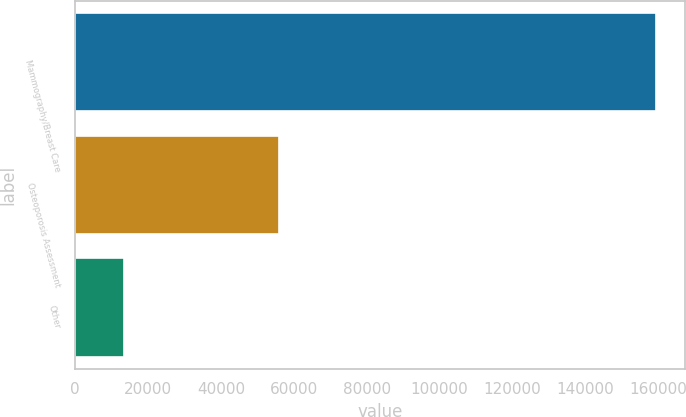Convert chart. <chart><loc_0><loc_0><loc_500><loc_500><bar_chart><fcel>Mammography/Breast Care<fcel>Osteoporosis Assessment<fcel>Other<nl><fcel>159469<fcel>56065<fcel>13541<nl></chart> 